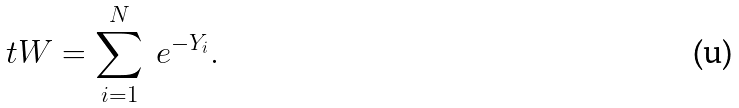<formula> <loc_0><loc_0><loc_500><loc_500>\ t W = \sum _ { i = 1 } ^ { N } \ e ^ { - Y _ { i } } .</formula> 